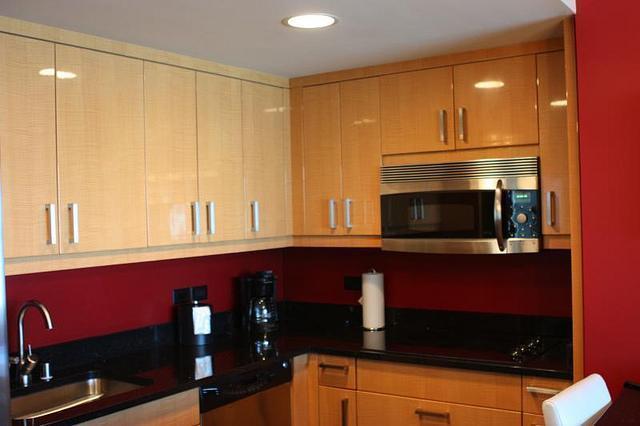What material is the sink made of?
Make your selection from the four choices given to correctly answer the question.
Options: Stainless steel, plastic, wood, porcelain. Stainless steel. 